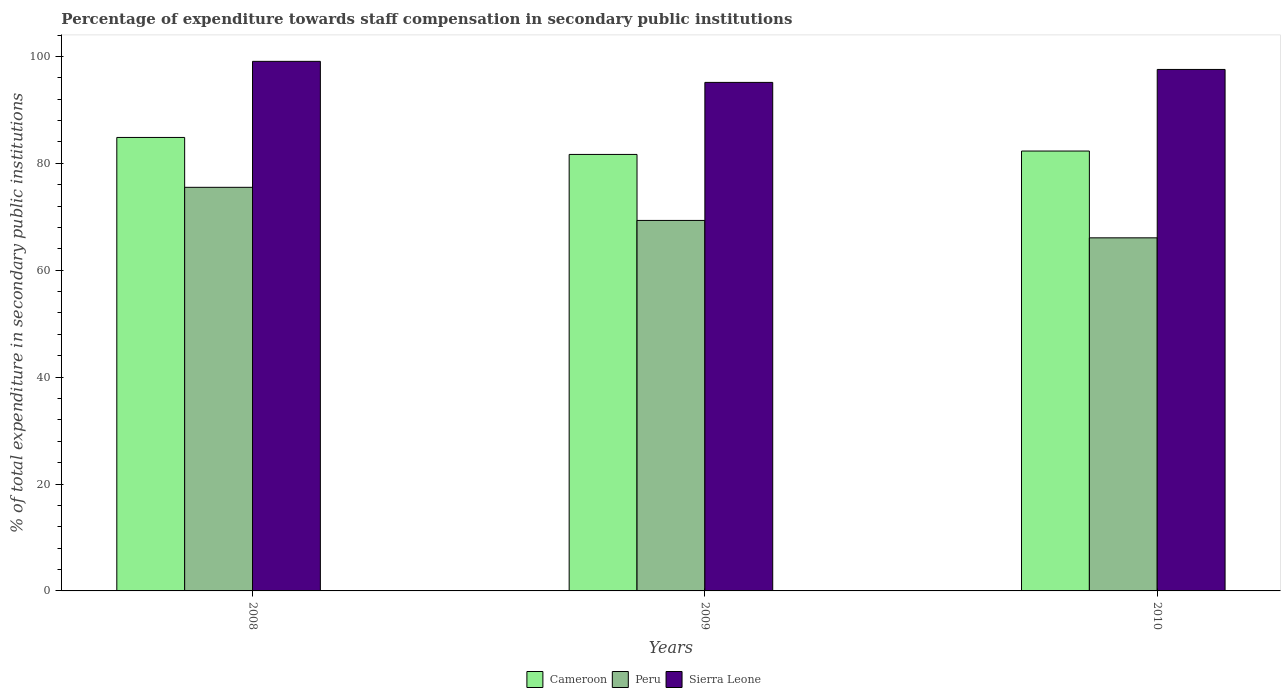How many different coloured bars are there?
Offer a very short reply. 3. How many groups of bars are there?
Provide a succinct answer. 3. How many bars are there on the 2nd tick from the left?
Your answer should be compact. 3. How many bars are there on the 2nd tick from the right?
Provide a short and direct response. 3. What is the percentage of expenditure towards staff compensation in Sierra Leone in 2009?
Provide a short and direct response. 95.14. Across all years, what is the maximum percentage of expenditure towards staff compensation in Peru?
Make the answer very short. 75.51. Across all years, what is the minimum percentage of expenditure towards staff compensation in Cameroon?
Your answer should be very brief. 81.67. In which year was the percentage of expenditure towards staff compensation in Peru maximum?
Give a very brief answer. 2008. In which year was the percentage of expenditure towards staff compensation in Cameroon minimum?
Provide a short and direct response. 2009. What is the total percentage of expenditure towards staff compensation in Cameroon in the graph?
Offer a very short reply. 248.82. What is the difference between the percentage of expenditure towards staff compensation in Cameroon in 2008 and that in 2010?
Offer a terse response. 2.54. What is the difference between the percentage of expenditure towards staff compensation in Sierra Leone in 2008 and the percentage of expenditure towards staff compensation in Cameroon in 2010?
Provide a short and direct response. 16.78. What is the average percentage of expenditure towards staff compensation in Peru per year?
Offer a very short reply. 70.3. In the year 2010, what is the difference between the percentage of expenditure towards staff compensation in Peru and percentage of expenditure towards staff compensation in Cameroon?
Ensure brevity in your answer.  -16.24. What is the ratio of the percentage of expenditure towards staff compensation in Sierra Leone in 2008 to that in 2010?
Give a very brief answer. 1.02. What is the difference between the highest and the second highest percentage of expenditure towards staff compensation in Peru?
Ensure brevity in your answer.  6.2. What is the difference between the highest and the lowest percentage of expenditure towards staff compensation in Peru?
Offer a very short reply. 9.45. What does the 2nd bar from the left in 2009 represents?
Keep it short and to the point. Peru. What does the 3rd bar from the right in 2008 represents?
Your answer should be very brief. Cameroon. Is it the case that in every year, the sum of the percentage of expenditure towards staff compensation in Sierra Leone and percentage of expenditure towards staff compensation in Peru is greater than the percentage of expenditure towards staff compensation in Cameroon?
Offer a very short reply. Yes. How many bars are there?
Ensure brevity in your answer.  9. Are all the bars in the graph horizontal?
Provide a short and direct response. No. Does the graph contain any zero values?
Your answer should be compact. No. Does the graph contain grids?
Your answer should be compact. No. How many legend labels are there?
Keep it short and to the point. 3. What is the title of the graph?
Give a very brief answer. Percentage of expenditure towards staff compensation in secondary public institutions. Does "Puerto Rico" appear as one of the legend labels in the graph?
Make the answer very short. No. What is the label or title of the X-axis?
Provide a short and direct response. Years. What is the label or title of the Y-axis?
Make the answer very short. % of total expenditure in secondary public institutions. What is the % of total expenditure in secondary public institutions of Cameroon in 2008?
Keep it short and to the point. 84.84. What is the % of total expenditure in secondary public institutions in Peru in 2008?
Ensure brevity in your answer.  75.51. What is the % of total expenditure in secondary public institutions of Sierra Leone in 2008?
Keep it short and to the point. 99.08. What is the % of total expenditure in secondary public institutions in Cameroon in 2009?
Offer a terse response. 81.67. What is the % of total expenditure in secondary public institutions of Peru in 2009?
Your response must be concise. 69.32. What is the % of total expenditure in secondary public institutions of Sierra Leone in 2009?
Ensure brevity in your answer.  95.14. What is the % of total expenditure in secondary public institutions of Cameroon in 2010?
Your response must be concise. 82.3. What is the % of total expenditure in secondary public institutions in Peru in 2010?
Provide a succinct answer. 66.06. What is the % of total expenditure in secondary public institutions of Sierra Leone in 2010?
Your answer should be very brief. 97.57. Across all years, what is the maximum % of total expenditure in secondary public institutions of Cameroon?
Offer a very short reply. 84.84. Across all years, what is the maximum % of total expenditure in secondary public institutions of Peru?
Your response must be concise. 75.51. Across all years, what is the maximum % of total expenditure in secondary public institutions in Sierra Leone?
Your response must be concise. 99.08. Across all years, what is the minimum % of total expenditure in secondary public institutions in Cameroon?
Offer a very short reply. 81.67. Across all years, what is the minimum % of total expenditure in secondary public institutions in Peru?
Offer a terse response. 66.06. Across all years, what is the minimum % of total expenditure in secondary public institutions in Sierra Leone?
Your answer should be compact. 95.14. What is the total % of total expenditure in secondary public institutions in Cameroon in the graph?
Offer a very short reply. 248.82. What is the total % of total expenditure in secondary public institutions of Peru in the graph?
Your answer should be very brief. 210.89. What is the total % of total expenditure in secondary public institutions in Sierra Leone in the graph?
Provide a short and direct response. 291.79. What is the difference between the % of total expenditure in secondary public institutions of Cameroon in 2008 and that in 2009?
Provide a succinct answer. 3.18. What is the difference between the % of total expenditure in secondary public institutions of Peru in 2008 and that in 2009?
Your response must be concise. 6.2. What is the difference between the % of total expenditure in secondary public institutions in Sierra Leone in 2008 and that in 2009?
Give a very brief answer. 3.94. What is the difference between the % of total expenditure in secondary public institutions in Cameroon in 2008 and that in 2010?
Your answer should be compact. 2.54. What is the difference between the % of total expenditure in secondary public institutions in Peru in 2008 and that in 2010?
Your response must be concise. 9.45. What is the difference between the % of total expenditure in secondary public institutions in Sierra Leone in 2008 and that in 2010?
Give a very brief answer. 1.51. What is the difference between the % of total expenditure in secondary public institutions in Cameroon in 2009 and that in 2010?
Offer a very short reply. -0.63. What is the difference between the % of total expenditure in secondary public institutions of Peru in 2009 and that in 2010?
Ensure brevity in your answer.  3.26. What is the difference between the % of total expenditure in secondary public institutions in Sierra Leone in 2009 and that in 2010?
Provide a short and direct response. -2.42. What is the difference between the % of total expenditure in secondary public institutions of Cameroon in 2008 and the % of total expenditure in secondary public institutions of Peru in 2009?
Offer a terse response. 15.53. What is the difference between the % of total expenditure in secondary public institutions in Cameroon in 2008 and the % of total expenditure in secondary public institutions in Sierra Leone in 2009?
Give a very brief answer. -10.3. What is the difference between the % of total expenditure in secondary public institutions of Peru in 2008 and the % of total expenditure in secondary public institutions of Sierra Leone in 2009?
Your answer should be very brief. -19.63. What is the difference between the % of total expenditure in secondary public institutions of Cameroon in 2008 and the % of total expenditure in secondary public institutions of Peru in 2010?
Make the answer very short. 18.78. What is the difference between the % of total expenditure in secondary public institutions in Cameroon in 2008 and the % of total expenditure in secondary public institutions in Sierra Leone in 2010?
Your answer should be very brief. -12.72. What is the difference between the % of total expenditure in secondary public institutions in Peru in 2008 and the % of total expenditure in secondary public institutions in Sierra Leone in 2010?
Your answer should be compact. -22.05. What is the difference between the % of total expenditure in secondary public institutions of Cameroon in 2009 and the % of total expenditure in secondary public institutions of Peru in 2010?
Your answer should be compact. 15.61. What is the difference between the % of total expenditure in secondary public institutions of Cameroon in 2009 and the % of total expenditure in secondary public institutions of Sierra Leone in 2010?
Provide a succinct answer. -15.9. What is the difference between the % of total expenditure in secondary public institutions of Peru in 2009 and the % of total expenditure in secondary public institutions of Sierra Leone in 2010?
Provide a succinct answer. -28.25. What is the average % of total expenditure in secondary public institutions of Cameroon per year?
Your response must be concise. 82.94. What is the average % of total expenditure in secondary public institutions of Peru per year?
Provide a short and direct response. 70.3. What is the average % of total expenditure in secondary public institutions in Sierra Leone per year?
Offer a terse response. 97.26. In the year 2008, what is the difference between the % of total expenditure in secondary public institutions in Cameroon and % of total expenditure in secondary public institutions in Peru?
Give a very brief answer. 9.33. In the year 2008, what is the difference between the % of total expenditure in secondary public institutions in Cameroon and % of total expenditure in secondary public institutions in Sierra Leone?
Your answer should be compact. -14.24. In the year 2008, what is the difference between the % of total expenditure in secondary public institutions of Peru and % of total expenditure in secondary public institutions of Sierra Leone?
Your answer should be very brief. -23.57. In the year 2009, what is the difference between the % of total expenditure in secondary public institutions of Cameroon and % of total expenditure in secondary public institutions of Peru?
Offer a very short reply. 12.35. In the year 2009, what is the difference between the % of total expenditure in secondary public institutions in Cameroon and % of total expenditure in secondary public institutions in Sierra Leone?
Keep it short and to the point. -13.47. In the year 2009, what is the difference between the % of total expenditure in secondary public institutions in Peru and % of total expenditure in secondary public institutions in Sierra Leone?
Offer a terse response. -25.82. In the year 2010, what is the difference between the % of total expenditure in secondary public institutions in Cameroon and % of total expenditure in secondary public institutions in Peru?
Your answer should be very brief. 16.24. In the year 2010, what is the difference between the % of total expenditure in secondary public institutions of Cameroon and % of total expenditure in secondary public institutions of Sierra Leone?
Your answer should be very brief. -15.27. In the year 2010, what is the difference between the % of total expenditure in secondary public institutions of Peru and % of total expenditure in secondary public institutions of Sierra Leone?
Keep it short and to the point. -31.51. What is the ratio of the % of total expenditure in secondary public institutions in Cameroon in 2008 to that in 2009?
Ensure brevity in your answer.  1.04. What is the ratio of the % of total expenditure in secondary public institutions in Peru in 2008 to that in 2009?
Give a very brief answer. 1.09. What is the ratio of the % of total expenditure in secondary public institutions of Sierra Leone in 2008 to that in 2009?
Ensure brevity in your answer.  1.04. What is the ratio of the % of total expenditure in secondary public institutions in Cameroon in 2008 to that in 2010?
Provide a short and direct response. 1.03. What is the ratio of the % of total expenditure in secondary public institutions in Peru in 2008 to that in 2010?
Ensure brevity in your answer.  1.14. What is the ratio of the % of total expenditure in secondary public institutions in Sierra Leone in 2008 to that in 2010?
Keep it short and to the point. 1.02. What is the ratio of the % of total expenditure in secondary public institutions in Peru in 2009 to that in 2010?
Your answer should be compact. 1.05. What is the ratio of the % of total expenditure in secondary public institutions of Sierra Leone in 2009 to that in 2010?
Make the answer very short. 0.98. What is the difference between the highest and the second highest % of total expenditure in secondary public institutions in Cameroon?
Your response must be concise. 2.54. What is the difference between the highest and the second highest % of total expenditure in secondary public institutions of Peru?
Your answer should be compact. 6.2. What is the difference between the highest and the second highest % of total expenditure in secondary public institutions in Sierra Leone?
Provide a succinct answer. 1.51. What is the difference between the highest and the lowest % of total expenditure in secondary public institutions in Cameroon?
Offer a very short reply. 3.18. What is the difference between the highest and the lowest % of total expenditure in secondary public institutions in Peru?
Your answer should be very brief. 9.45. What is the difference between the highest and the lowest % of total expenditure in secondary public institutions of Sierra Leone?
Make the answer very short. 3.94. 